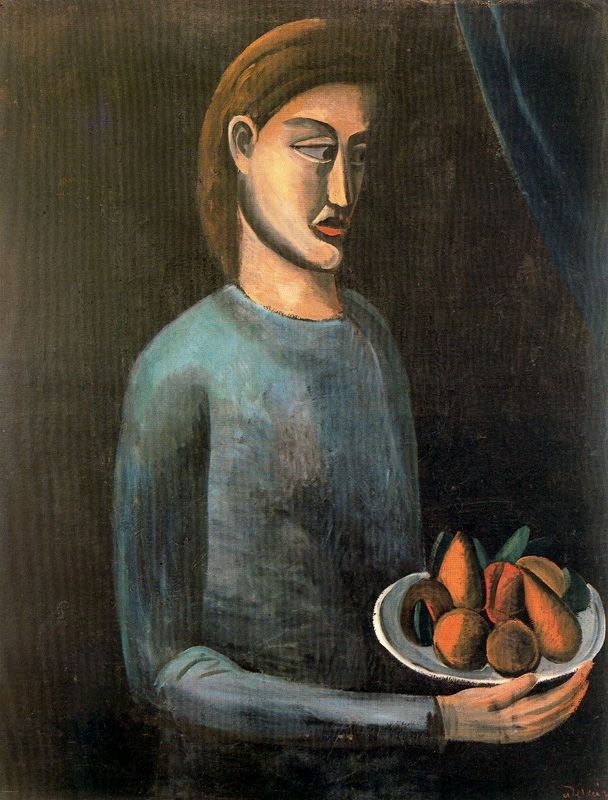Explain the visual content of the image in great detail. The image portrays a woman, the central figure of the artwork, holding a bowl filled with fruit. The woman is depicted in a modernist style, characterized by simplified geometric forms and a less realistic representation. She is dressed in a blue shirt, which stands out against the dark background. Her face is elongated, with a prominent nose, a common feature in modernist portraiture. The bowl she holds is brimming with oranges and pears, their vibrant colors adding a contrast to the otherwise muted palette of the painting. This artwork likely originates from the early 20th century, a period when the modern art movement was gaining momentum. The painting's emphasis on form and color over detail is a hallmark of this genre. 